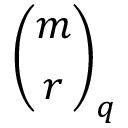<formula> <loc_0><loc_0><loc_500><loc_500>{ \binom { m } { r } } _ { q }</formula> 